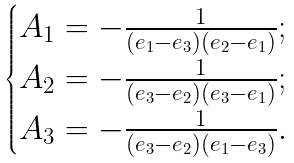Convert formula to latex. <formula><loc_0><loc_0><loc_500><loc_500>\begin{cases} A _ { 1 } = - \frac { 1 } { ( e _ { 1 } - e _ { 3 } ) ( e _ { 2 } - e _ { 1 } ) } ; \\ A _ { 2 } = - \frac { 1 } { ( e _ { 3 } - e _ { 2 } ) ( e _ { 3 } - e _ { 1 } ) } ; \\ A _ { 3 } = - \frac { 1 } { ( e _ { 3 } - e _ { 2 } ) ( e _ { 1 } - e _ { 3 } ) } . \\ \end{cases}</formula> 